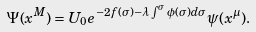Convert formula to latex. <formula><loc_0><loc_0><loc_500><loc_500>\Psi ( x ^ { M } ) = U _ { 0 } e ^ { - 2 f ( \sigma ) - \lambda \int ^ { \sigma } \phi ( \sigma ) d \sigma } \psi ( x ^ { \mu } ) .</formula> 